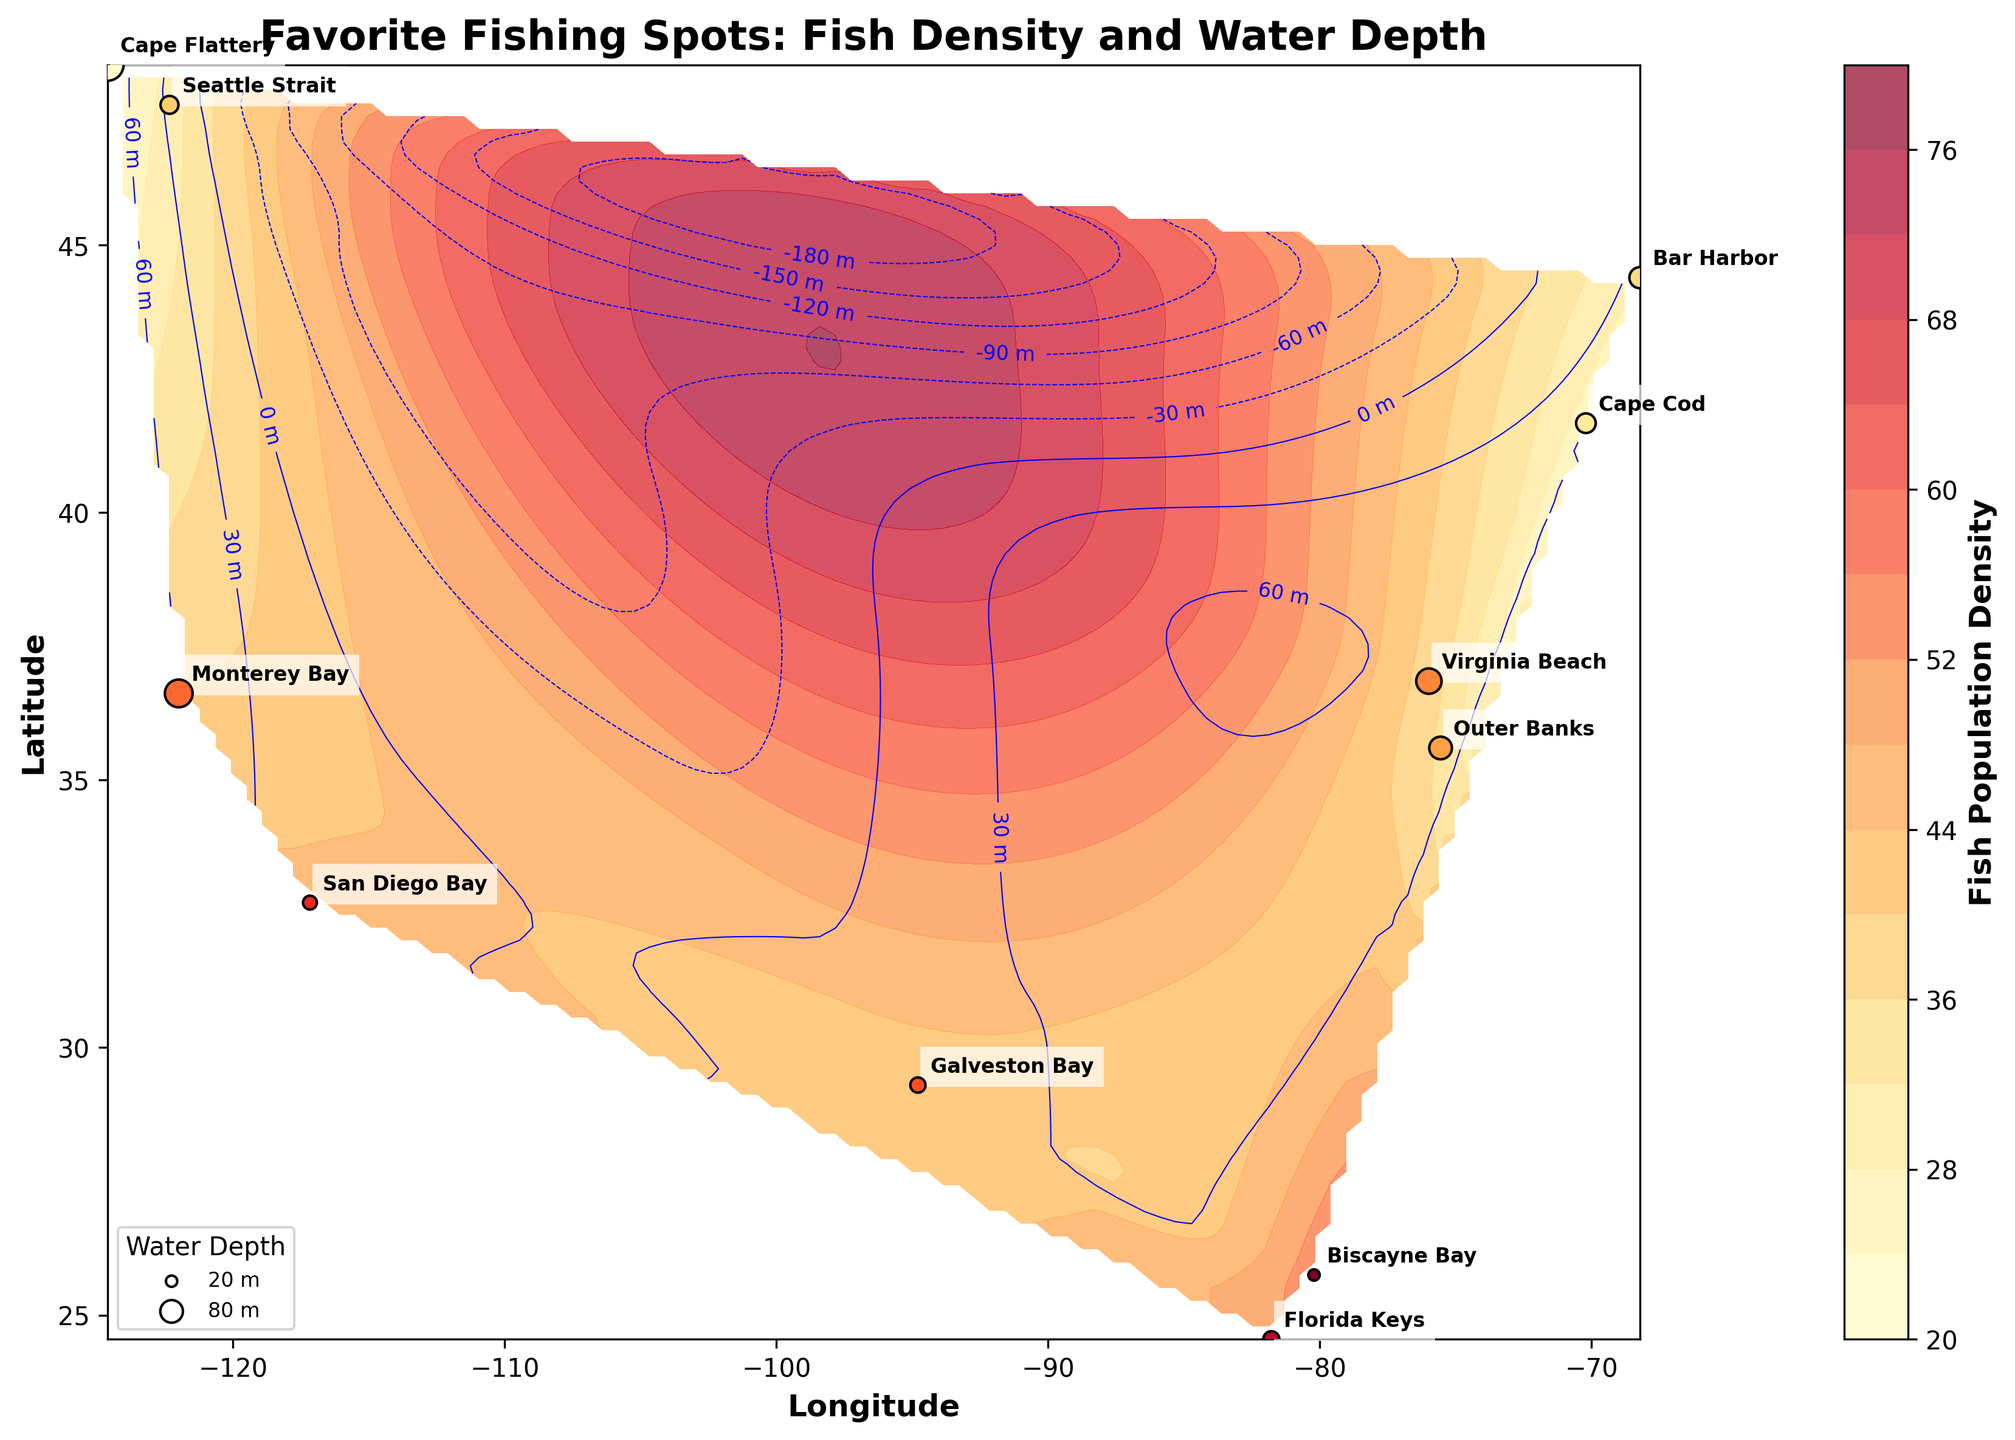What does the title of the plot indicate about the data? The title of the plot is "Favorite Fishing Spots: Fish Density and Water Depth," which indicates that the plot visualizes favorite fishing spots along with their fish population density and water depth information.
Answer: Favorite Fishing Spots: Fish Density and Water Depth How many fishing spots are shown on the plot? The figure shows points annotated with fishing spot names. By counting these, we see 11 fishing spots are labeled on the plot.
Answer: 11 Which fishing spot has the highest fish population density? From the color intensity in the contour plot and matching the annotated spots' color, we see that Biscayne Bay has the highest fish population density.
Answer: Biscayne Bay Which fishing spot has the deepest water depth and what is that depth? The deepest water depth is represented by the largest circles on the plot, and Cape Flattery has the deepest water depth of 80 meters.
Answer: Cape Flattery, 80 meters How does the fish population density vary with water depth in San Diego Bay and Galveston Bay? San Diego Bay has a fish population density of 45 and a water depth of 15 meters. Galveston Bay has a density of 42 and a depth of 18 meters. Both spots have relatively high fish population densities accompanied by shallower water depths.
Answer: San Diego Bay: 45 density, 15 meters depth; Galveston Bay: 42 density, 18 meters depth Which fishing spot has both high fish population density and shallow water depth? Biscayne Bay fits this criterion with a fish population density of 55 and a water depth of 10 meters.
Answer: Biscayne Bay Are there any fishing spots with low fish population density but deep waters? Cape Flattery is an example with a low fish population density of 20 and a water depth of 80 meters.
Answer: Cape Flattery If you are looking for moderately deep waters (around 40 meters) but good fish density, which fishing spot would you choose? Outer Banks has a moderate water depth of 40 meters and a good fish population density of 35.
Answer: Outer Banks 